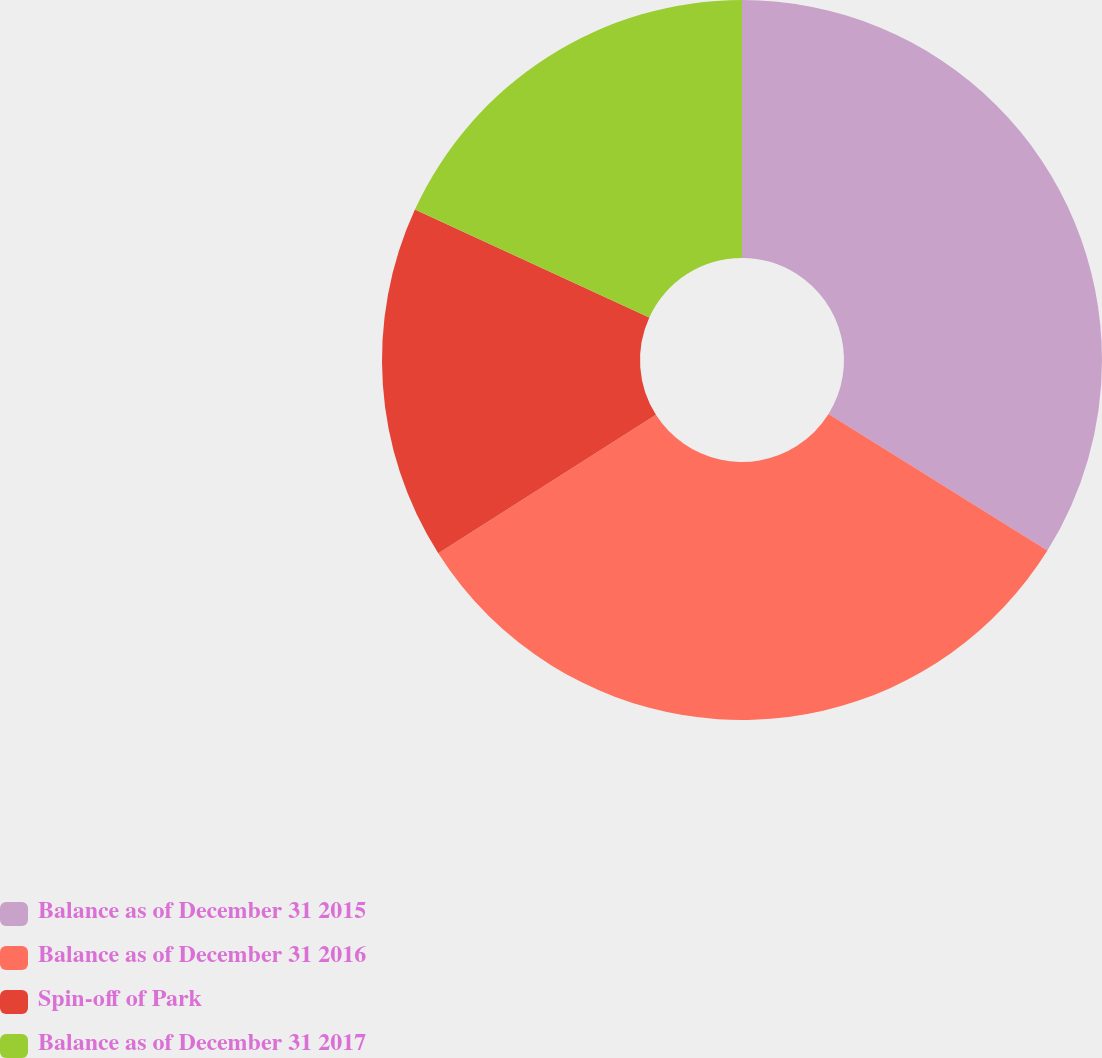<chart> <loc_0><loc_0><loc_500><loc_500><pie_chart><fcel>Balance as of December 31 2015<fcel>Balance as of December 31 2016<fcel>Spin-off of Park<fcel>Balance as of December 31 2017<nl><fcel>33.88%<fcel>32.1%<fcel>15.88%<fcel>18.14%<nl></chart> 